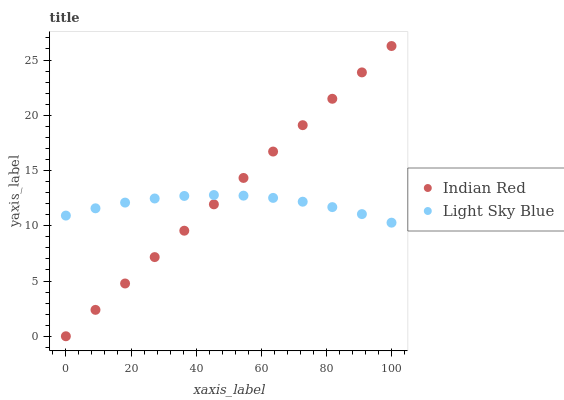Does Light Sky Blue have the minimum area under the curve?
Answer yes or no. Yes. Does Indian Red have the maximum area under the curve?
Answer yes or no. Yes. Does Indian Red have the minimum area under the curve?
Answer yes or no. No. Is Indian Red the smoothest?
Answer yes or no. Yes. Is Light Sky Blue the roughest?
Answer yes or no. Yes. Is Indian Red the roughest?
Answer yes or no. No. Does Indian Red have the lowest value?
Answer yes or no. Yes. Does Indian Red have the highest value?
Answer yes or no. Yes. Does Indian Red intersect Light Sky Blue?
Answer yes or no. Yes. Is Indian Red less than Light Sky Blue?
Answer yes or no. No. Is Indian Red greater than Light Sky Blue?
Answer yes or no. No. 